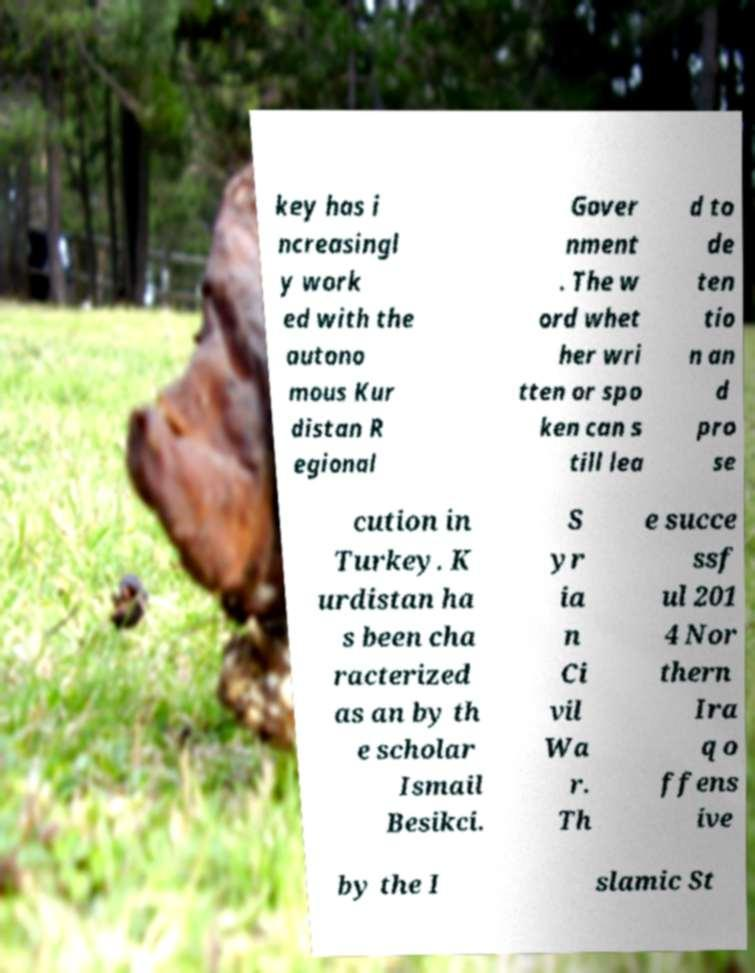There's text embedded in this image that I need extracted. Can you transcribe it verbatim? key has i ncreasingl y work ed with the autono mous Kur distan R egional Gover nment . The w ord whet her wri tten or spo ken can s till lea d to de ten tio n an d pro se cution in Turkey. K urdistan ha s been cha racterized as an by th e scholar Ismail Besikci. S yr ia n Ci vil Wa r. Th e succe ssf ul 201 4 Nor thern Ira q o ffens ive by the I slamic St 